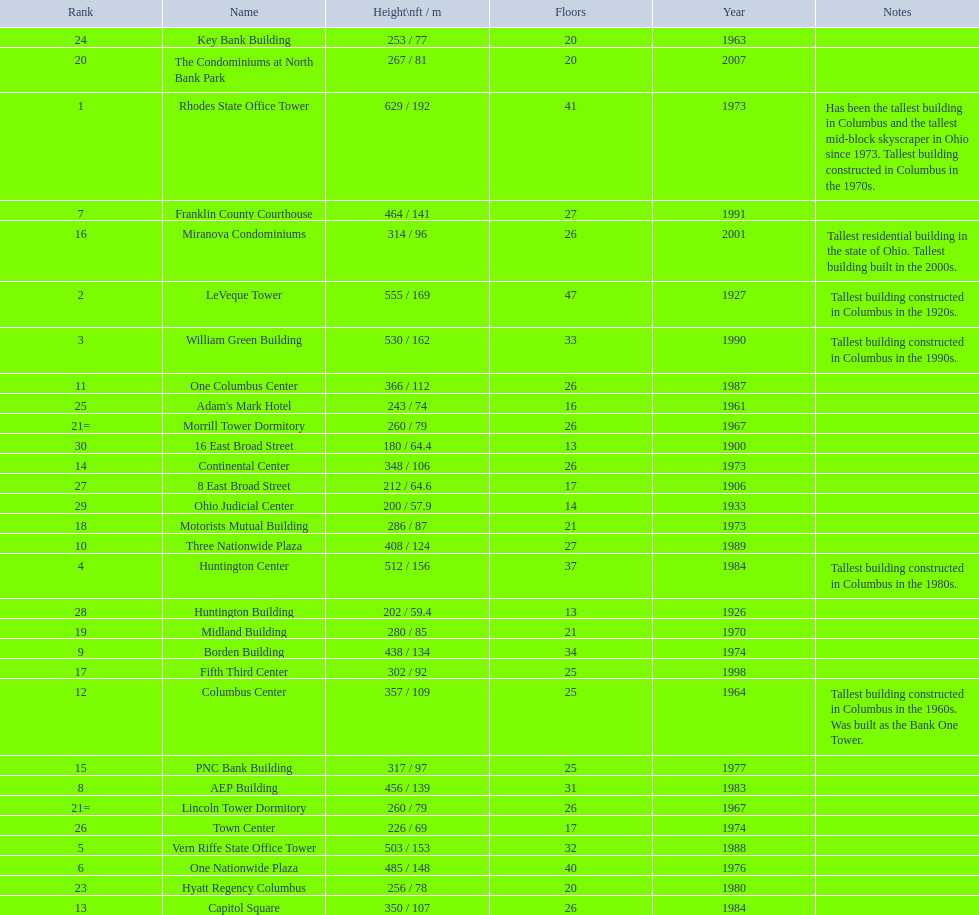What are the heights of all the buildings 629 / 192, 555 / 169, 530 / 162, 512 / 156, 503 / 153, 485 / 148, 464 / 141, 456 / 139, 438 / 134, 408 / 124, 366 / 112, 357 / 109, 350 / 107, 348 / 106, 317 / 97, 314 / 96, 302 / 92, 286 / 87, 280 / 85, 267 / 81, 260 / 79, 260 / 79, 256 / 78, 253 / 77, 243 / 74, 226 / 69, 212 / 64.6, 202 / 59.4, 200 / 57.9, 180 / 64.4. What are the heights of the aep and columbus center buildings 456 / 139, 357 / 109. Which height is greater? 456 / 139. What building is this for? AEP Building. 